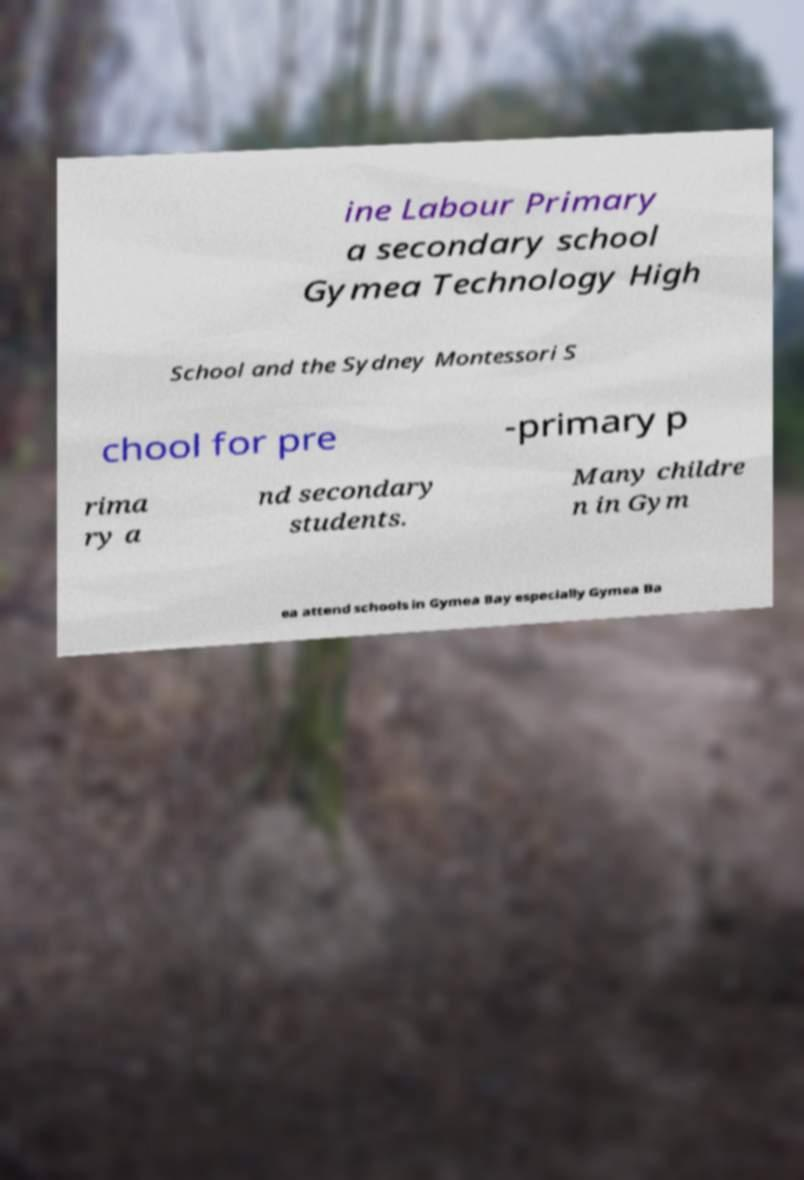Please read and relay the text visible in this image. What does it say? ine Labour Primary a secondary school Gymea Technology High School and the Sydney Montessori S chool for pre -primary p rima ry a nd secondary students. Many childre n in Gym ea attend schools in Gymea Bay especially Gymea Ba 